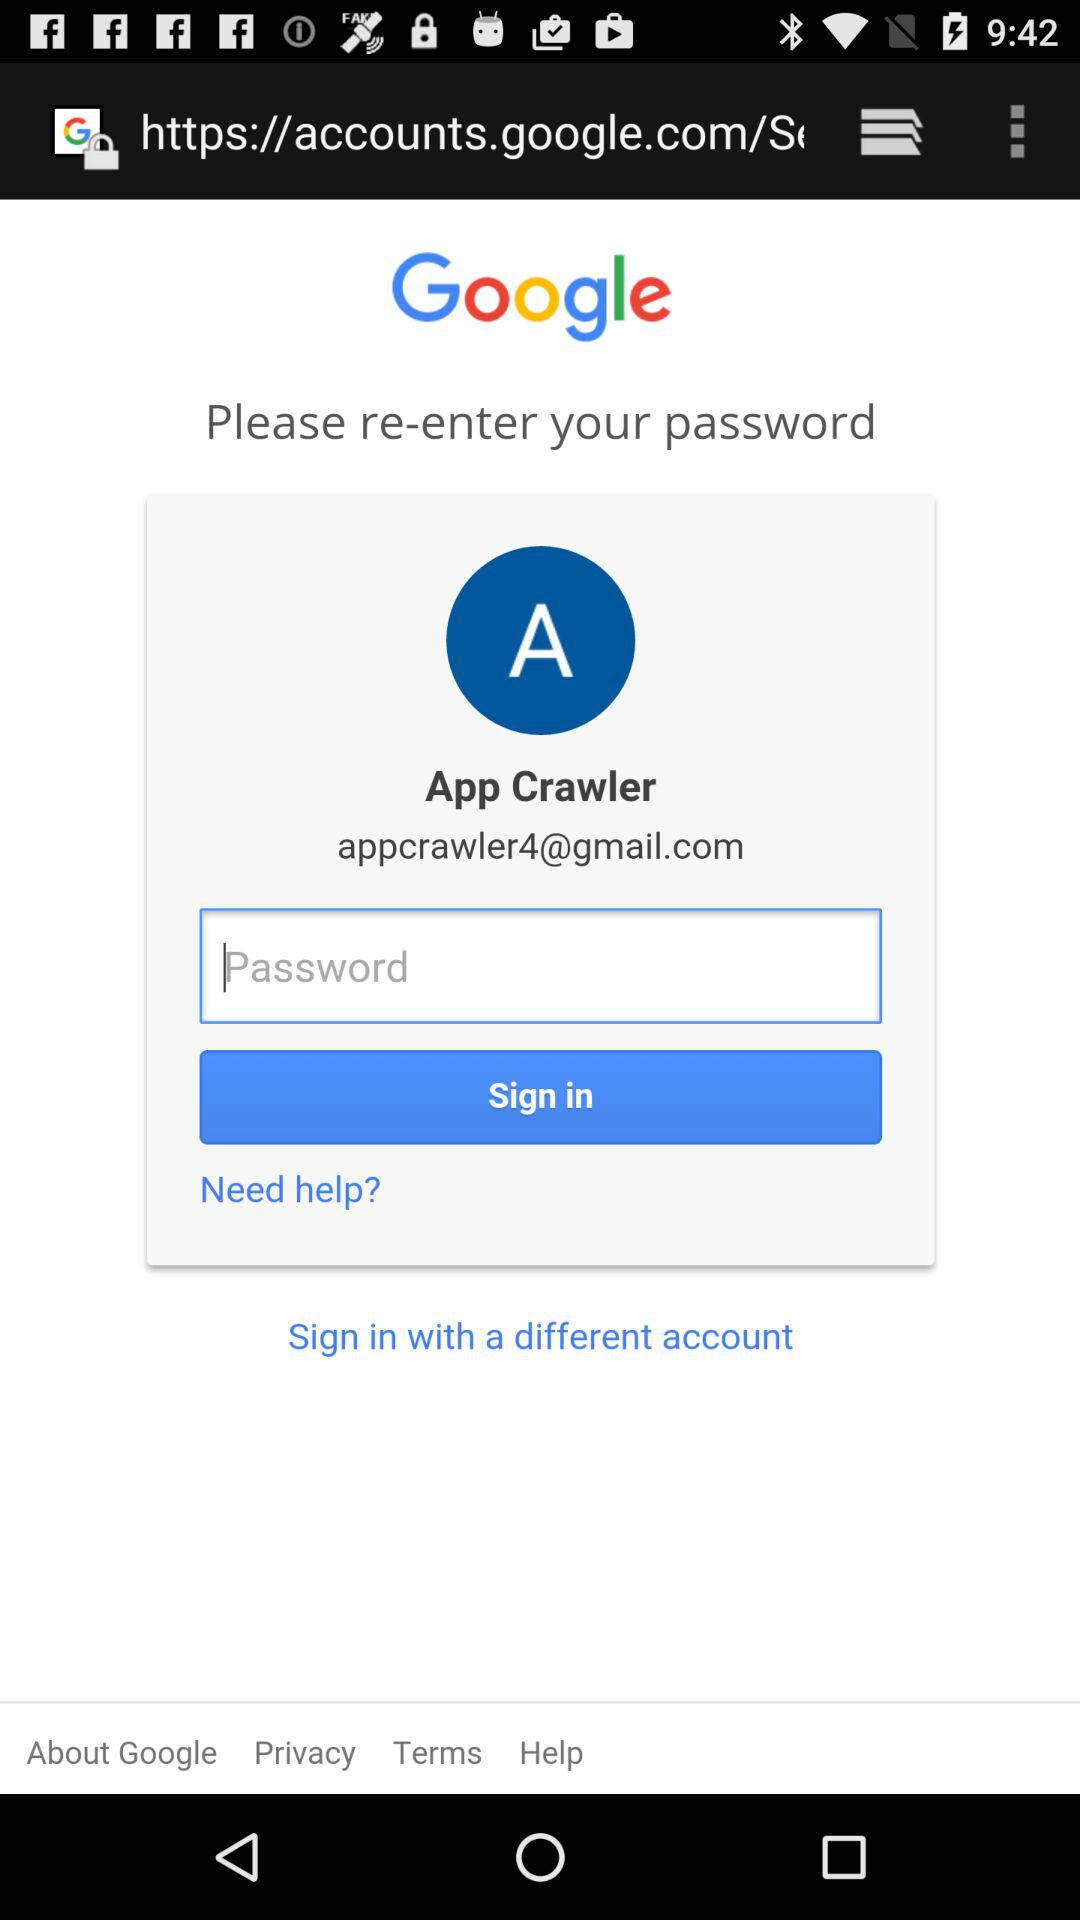What is the email address? The email address is appcrawler4@gmail.com. 